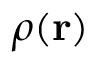Convert formula to latex. <formula><loc_0><loc_0><loc_500><loc_500>\rho ( r )</formula> 